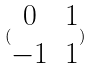Convert formula to latex. <formula><loc_0><loc_0><loc_500><loc_500>( \begin{matrix} 0 & 1 \\ - 1 & 1 \end{matrix} )</formula> 